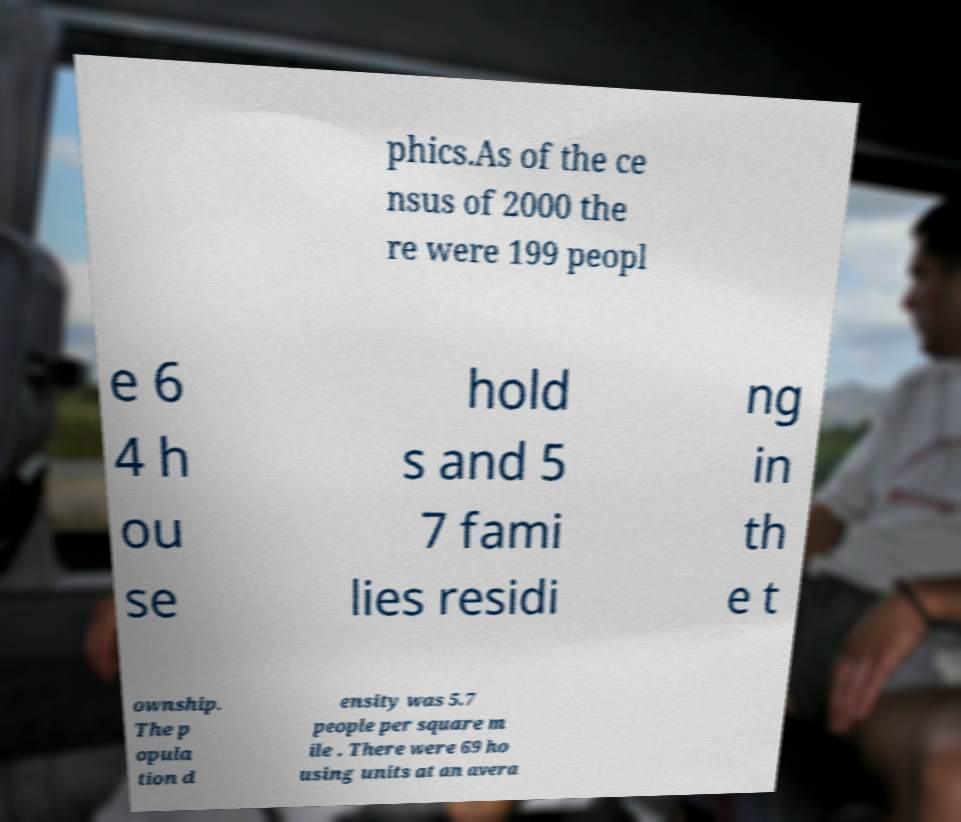There's text embedded in this image that I need extracted. Can you transcribe it verbatim? phics.As of the ce nsus of 2000 the re were 199 peopl e 6 4 h ou se hold s and 5 7 fami lies residi ng in th e t ownship. The p opula tion d ensity was 5.7 people per square m ile . There were 69 ho using units at an avera 